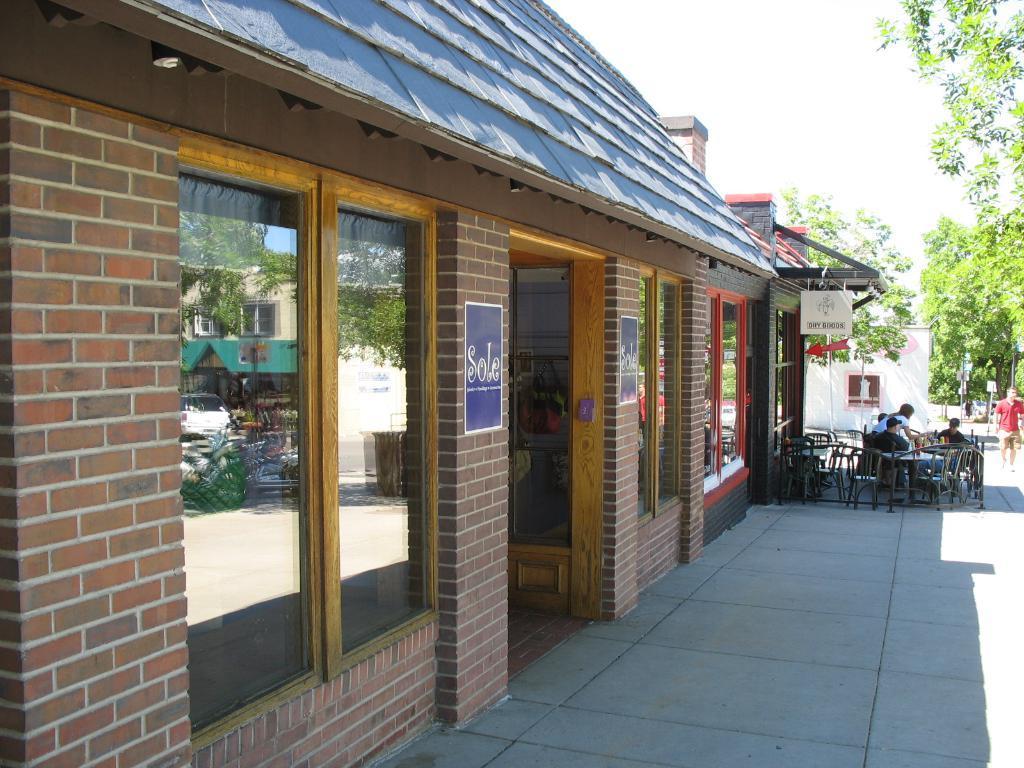Can you describe this image briefly? In this image we can see the buildings, there are chairs, people, trees, posters and a table with some objects, also we can see the poles with boards, in the background, we can see the sky. 